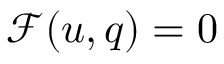Convert formula to latex. <formula><loc_0><loc_0><loc_500><loc_500>\begin{array} { r } { \mathcal { F } ( u , q ) = 0 } \end{array}</formula> 